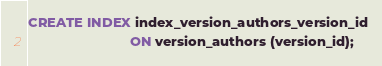<code> <loc_0><loc_0><loc_500><loc_500><_SQL_>CREATE INDEX index_version_authors_version_id
                           ON version_authors (version_id);</code> 